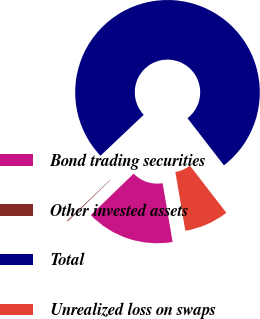Convert chart to OTSL. <chart><loc_0><loc_0><loc_500><loc_500><pie_chart><fcel>Bond trading securities<fcel>Other invested assets<fcel>Total<fcel>Unrealized loss on swaps<nl><fcel>15.45%<fcel>0.16%<fcel>76.59%<fcel>7.8%<nl></chart> 